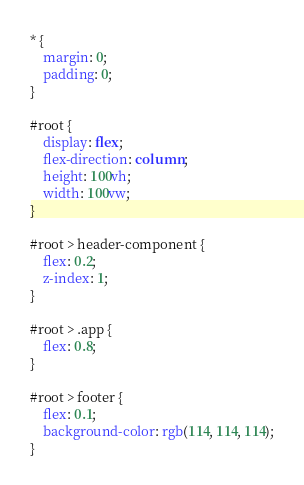Convert code to text. <code><loc_0><loc_0><loc_500><loc_500><_CSS_>* {
    margin: 0;
    padding: 0;
}

#root {
    display: flex;
    flex-direction: column;
    height: 100vh;
    width: 100vw;
}

#root > header-component {
    flex: 0.2;
    z-index: 1;
}

#root > .app {
    flex: 0.8;
}

#root > footer {
    flex: 0.1;
    background-color: rgb(114, 114, 114);
}
</code> 